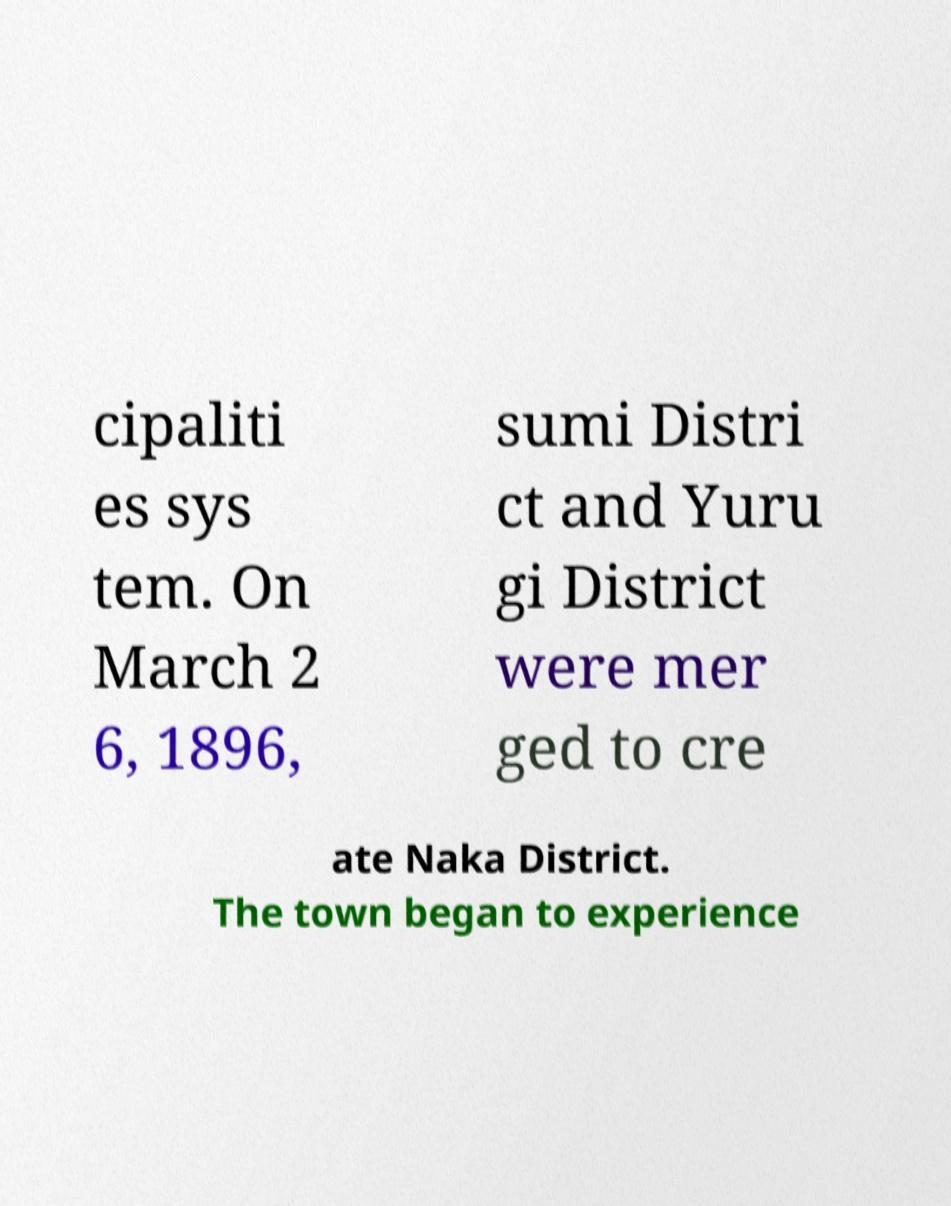Could you assist in decoding the text presented in this image and type it out clearly? cipaliti es sys tem. On March 2 6, 1896, sumi Distri ct and Yuru gi District were mer ged to cre ate Naka District. The town began to experience 